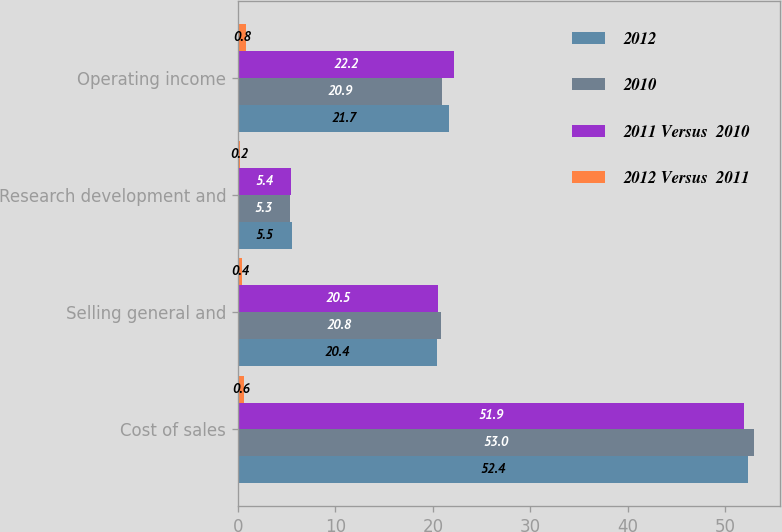Convert chart to OTSL. <chart><loc_0><loc_0><loc_500><loc_500><stacked_bar_chart><ecel><fcel>Cost of sales<fcel>Selling general and<fcel>Research development and<fcel>Operating income<nl><fcel>2012<fcel>52.4<fcel>20.4<fcel>5.5<fcel>21.7<nl><fcel>2010<fcel>53<fcel>20.8<fcel>5.3<fcel>20.9<nl><fcel>2011 Versus  2010<fcel>51.9<fcel>20.5<fcel>5.4<fcel>22.2<nl><fcel>2012 Versus  2011<fcel>0.6<fcel>0.4<fcel>0.2<fcel>0.8<nl></chart> 